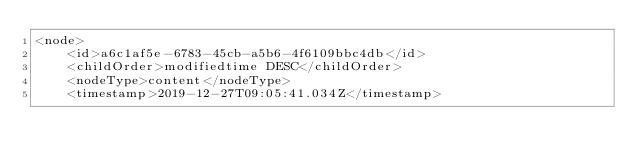<code> <loc_0><loc_0><loc_500><loc_500><_XML_><node>
    <id>a6c1af5e-6783-45cb-a5b6-4f6109bbc4db</id>
    <childOrder>modifiedtime DESC</childOrder>
    <nodeType>content</nodeType>
    <timestamp>2019-12-27T09:05:41.034Z</timestamp></code> 